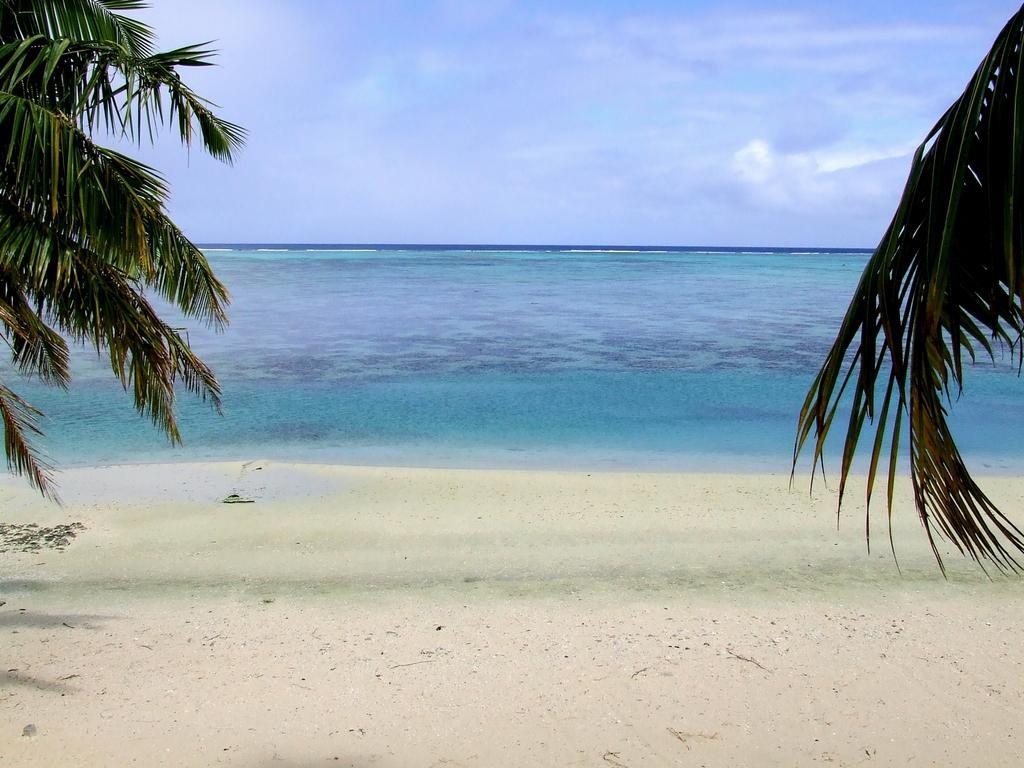Describe this image in one or two sentences. In this picture we can see trees, sand, water and in the background we can see the sky with clouds. 